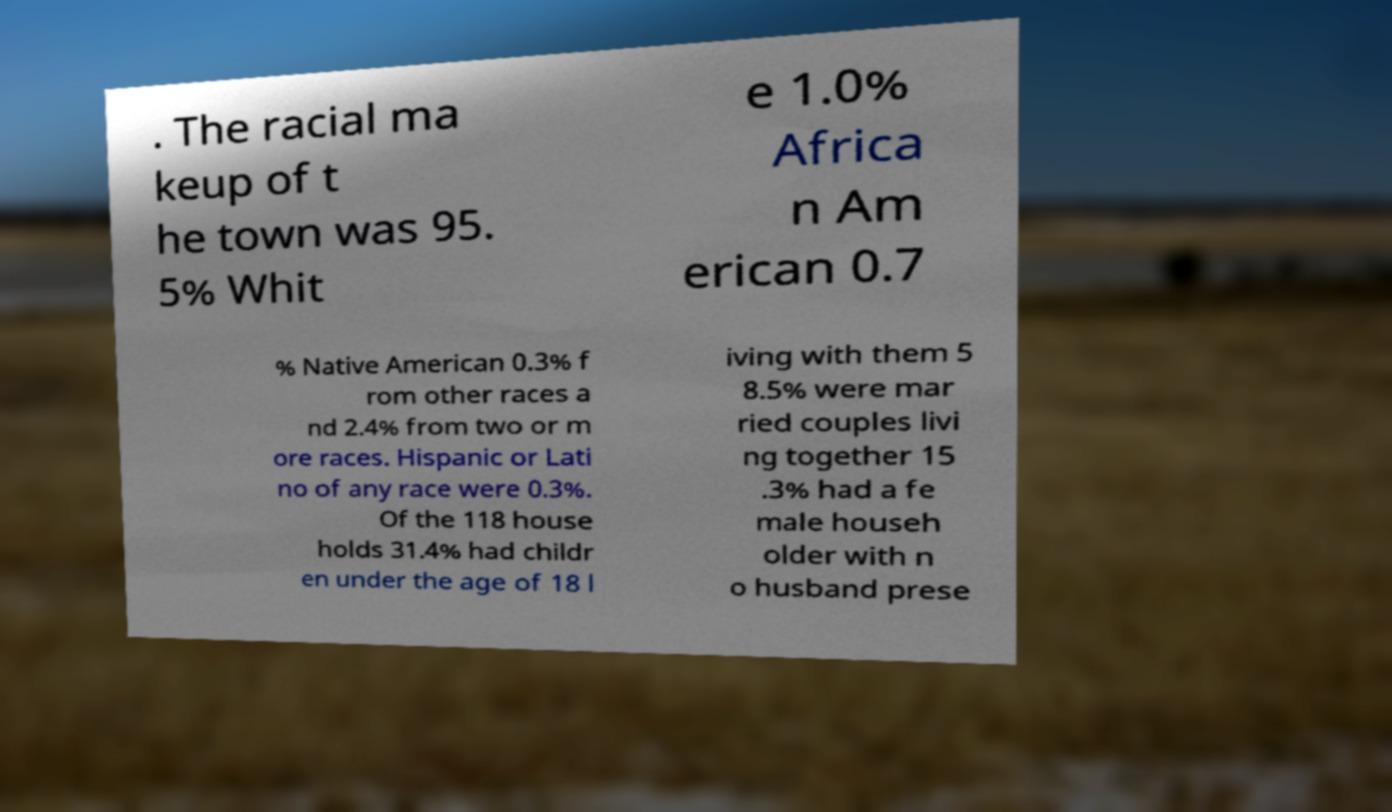There's text embedded in this image that I need extracted. Can you transcribe it verbatim? . The racial ma keup of t he town was 95. 5% Whit e 1.0% Africa n Am erican 0.7 % Native American 0.3% f rom other races a nd 2.4% from two or m ore races. Hispanic or Lati no of any race were 0.3%. Of the 118 house holds 31.4% had childr en under the age of 18 l iving with them 5 8.5% were mar ried couples livi ng together 15 .3% had a fe male househ older with n o husband prese 